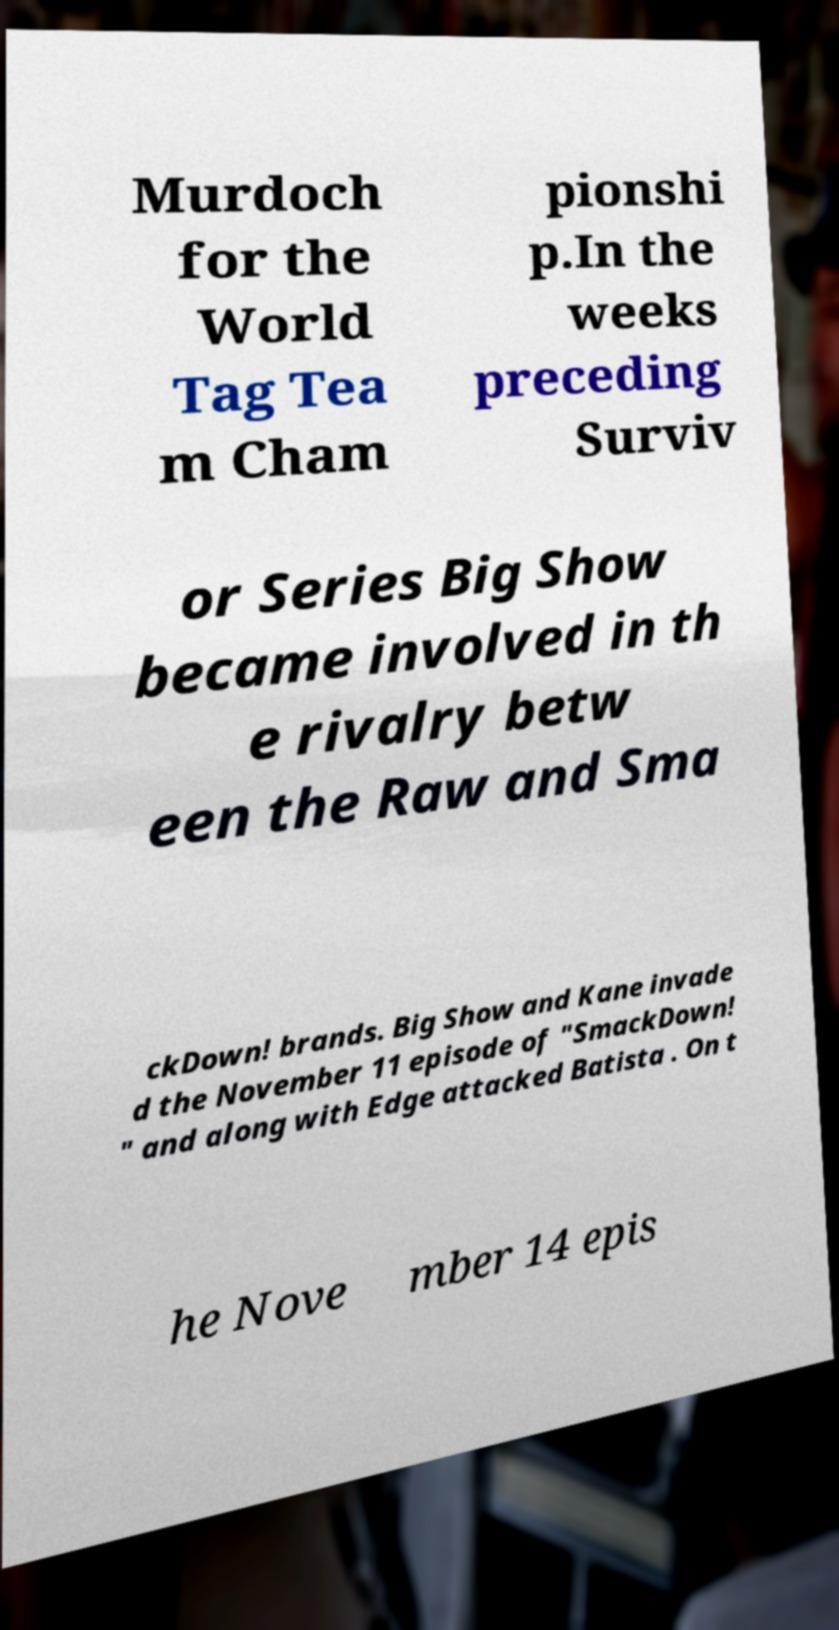Can you accurately transcribe the text from the provided image for me? Murdoch for the World Tag Tea m Cham pionshi p.In the weeks preceding Surviv or Series Big Show became involved in th e rivalry betw een the Raw and Sma ckDown! brands. Big Show and Kane invade d the November 11 episode of "SmackDown! " and along with Edge attacked Batista . On t he Nove mber 14 epis 